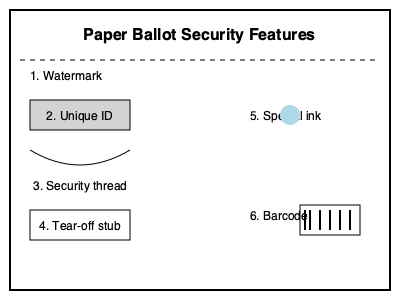Analyze the security features of the paper ballot shown in the diagram. Which feature primarily helps in preventing ballot box stuffing and ensures each voter only casts one vote? To determine which security feature primarily prevents ballot box stuffing and ensures each voter only casts one vote, let's examine each feature:

1. Watermark: Helps verify the authenticity of the ballot paper but doesn't prevent multiple voting.

2. Unique ID: This is crucial for preventing ballot box stuffing. Each ballot has a unique identifier, making it impossible to introduce duplicate or unauthorized ballots.

3. Security thread: Enhances the overall security of the ballot paper but doesn't directly prevent multiple voting.

4. Tear-off stub: While this can be used to track the number of ballots issued, it doesn't prevent a voter from casting multiple ballots.

5. Special ink: Typically used to mark choices and prevent tampering with votes, but doesn't prevent multiple voting.

6. Barcode: Can contain ballot information but doesn't inherently prevent multiple voting.

The Unique ID (feature 2) is the primary safeguard against ballot box stuffing. It ensures that each ballot can be accounted for and prevents the introduction of unauthorized ballots. When combined with voter registration checks, it effectively limits each voter to casting only one vote.
Answer: Unique ID 